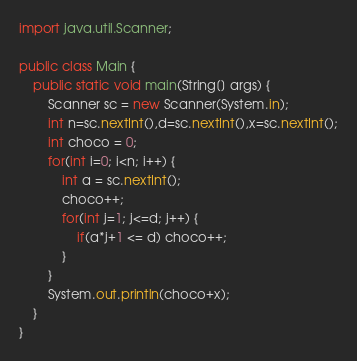Convert code to text. <code><loc_0><loc_0><loc_500><loc_500><_Java_>import java.util.Scanner;

public class Main {
	public static void main(String[] args) {
		Scanner sc = new Scanner(System.in);
		int n=sc.nextInt(),d=sc.nextInt(),x=sc.nextInt();
		int choco = 0;
		for(int i=0; i<n; i++) {
			int a = sc.nextInt();
			choco++;
			for(int j=1; j<=d; j++) {
				if(a*j+1 <= d) choco++;
			}
		}
		System.out.println(choco+x);
	}
}
</code> 